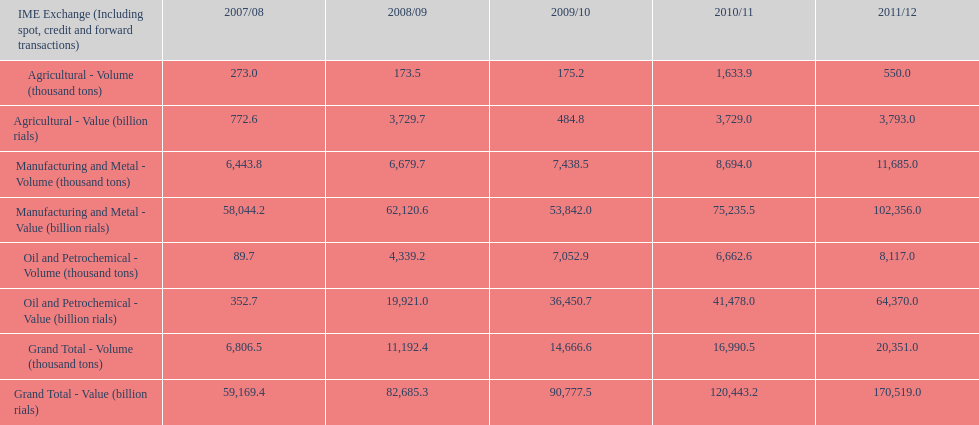Over how many uninterrupted years did the cumulative total value rise in iran? 4. 